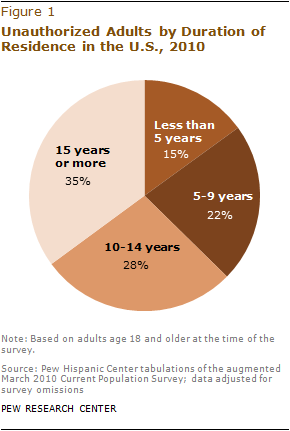Identify some key points in this picture. The addition of the average and medians of all the segments results in a value that is less than the sum of the two largest segments. Approximately 22% of unauthorized adults who had been U.S. residents for 5-9 years were not born in the United States. 